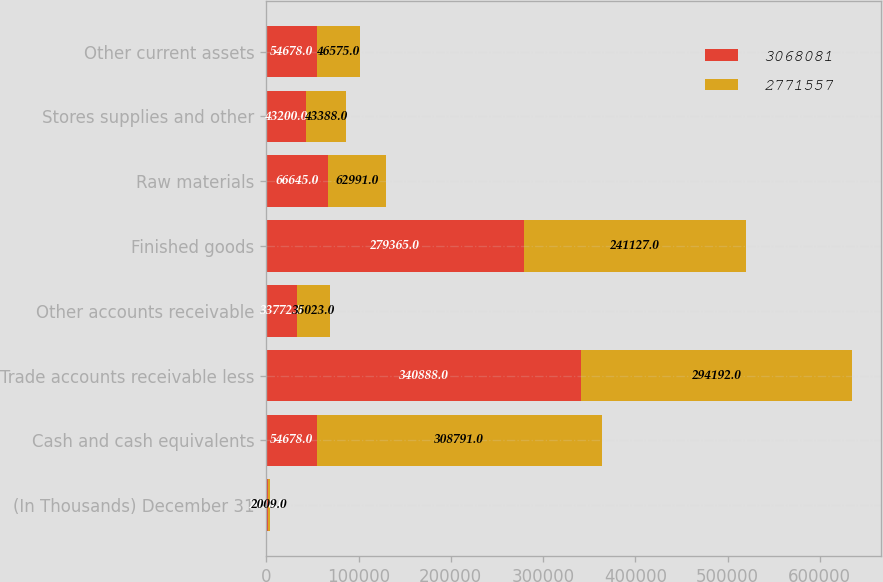Convert chart to OTSL. <chart><loc_0><loc_0><loc_500><loc_500><stacked_bar_chart><ecel><fcel>(In Thousands) December 31<fcel>Cash and cash equivalents<fcel>Trade accounts receivable less<fcel>Other accounts receivable<fcel>Finished goods<fcel>Raw materials<fcel>Stores supplies and other<fcel>Other current assets<nl><fcel>3.06808e+06<fcel>2010<fcel>54678<fcel>340888<fcel>33772<fcel>279365<fcel>66645<fcel>43200<fcel>54678<nl><fcel>2.77156e+06<fcel>2009<fcel>308791<fcel>294192<fcel>35023<fcel>241127<fcel>62991<fcel>43388<fcel>46575<nl></chart> 